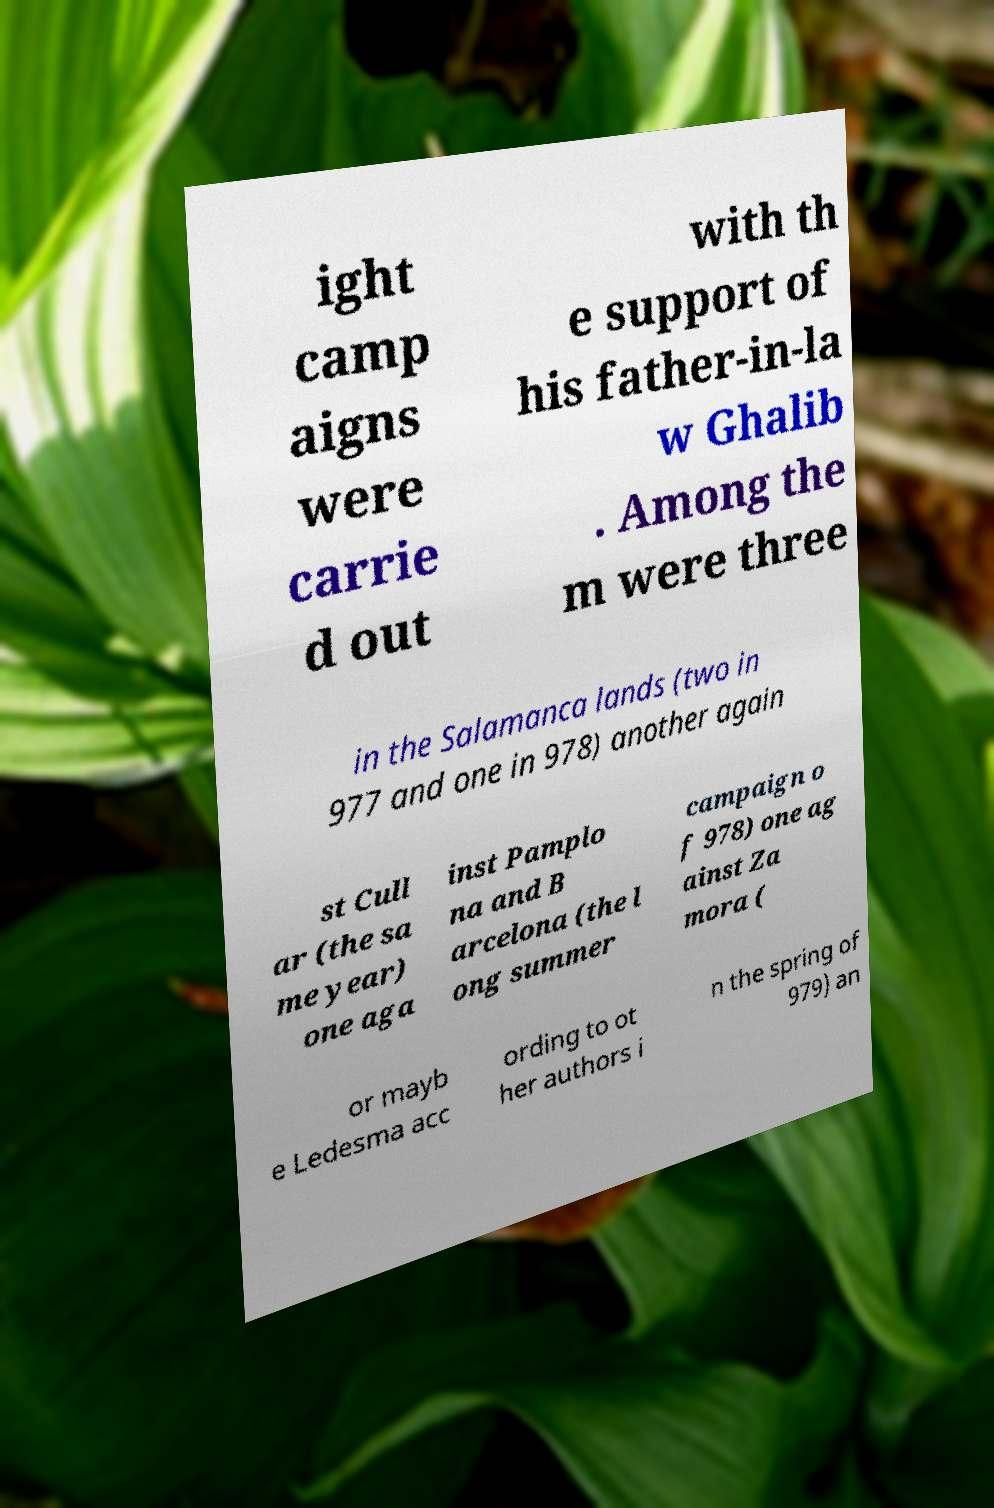Can you read and provide the text displayed in the image?This photo seems to have some interesting text. Can you extract and type it out for me? ight camp aigns were carrie d out with th e support of his father-in-la w Ghalib . Among the m were three in the Salamanca lands (two in 977 and one in 978) another again st Cull ar (the sa me year) one aga inst Pamplo na and B arcelona (the l ong summer campaign o f 978) one ag ainst Za mora ( or mayb e Ledesma acc ording to ot her authors i n the spring of 979) an 